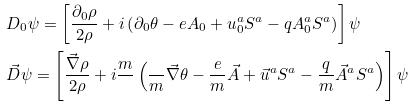<formula> <loc_0><loc_0><loc_500><loc_500>& D _ { 0 } \psi = \left [ \frac { \partial _ { 0 } \rho } { 2 \rho } + i \left ( \partial _ { 0 } \theta - e A _ { 0 } + u _ { 0 } ^ { a } S ^ { a } - q A ^ { a } _ { 0 } S ^ { a } \right ) \right ] \psi \\ & \vec { D } \psi = \left [ \frac { \vec { \nabla } \rho } { 2 \rho } + i \frac { m } { } \left ( \frac { } { m } \vec { \nabla } \theta - \frac { e } { m } \vec { A } + \vec { u } ^ { a } S ^ { a } - \frac { q } { m } \vec { A } ^ { a } S ^ { a } \right ) \right ] \psi</formula> 